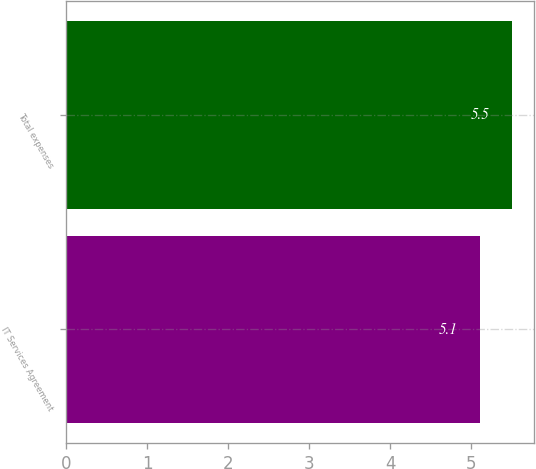Convert chart. <chart><loc_0><loc_0><loc_500><loc_500><bar_chart><fcel>IT Services Agreement<fcel>Total expenses<nl><fcel>5.1<fcel>5.5<nl></chart> 